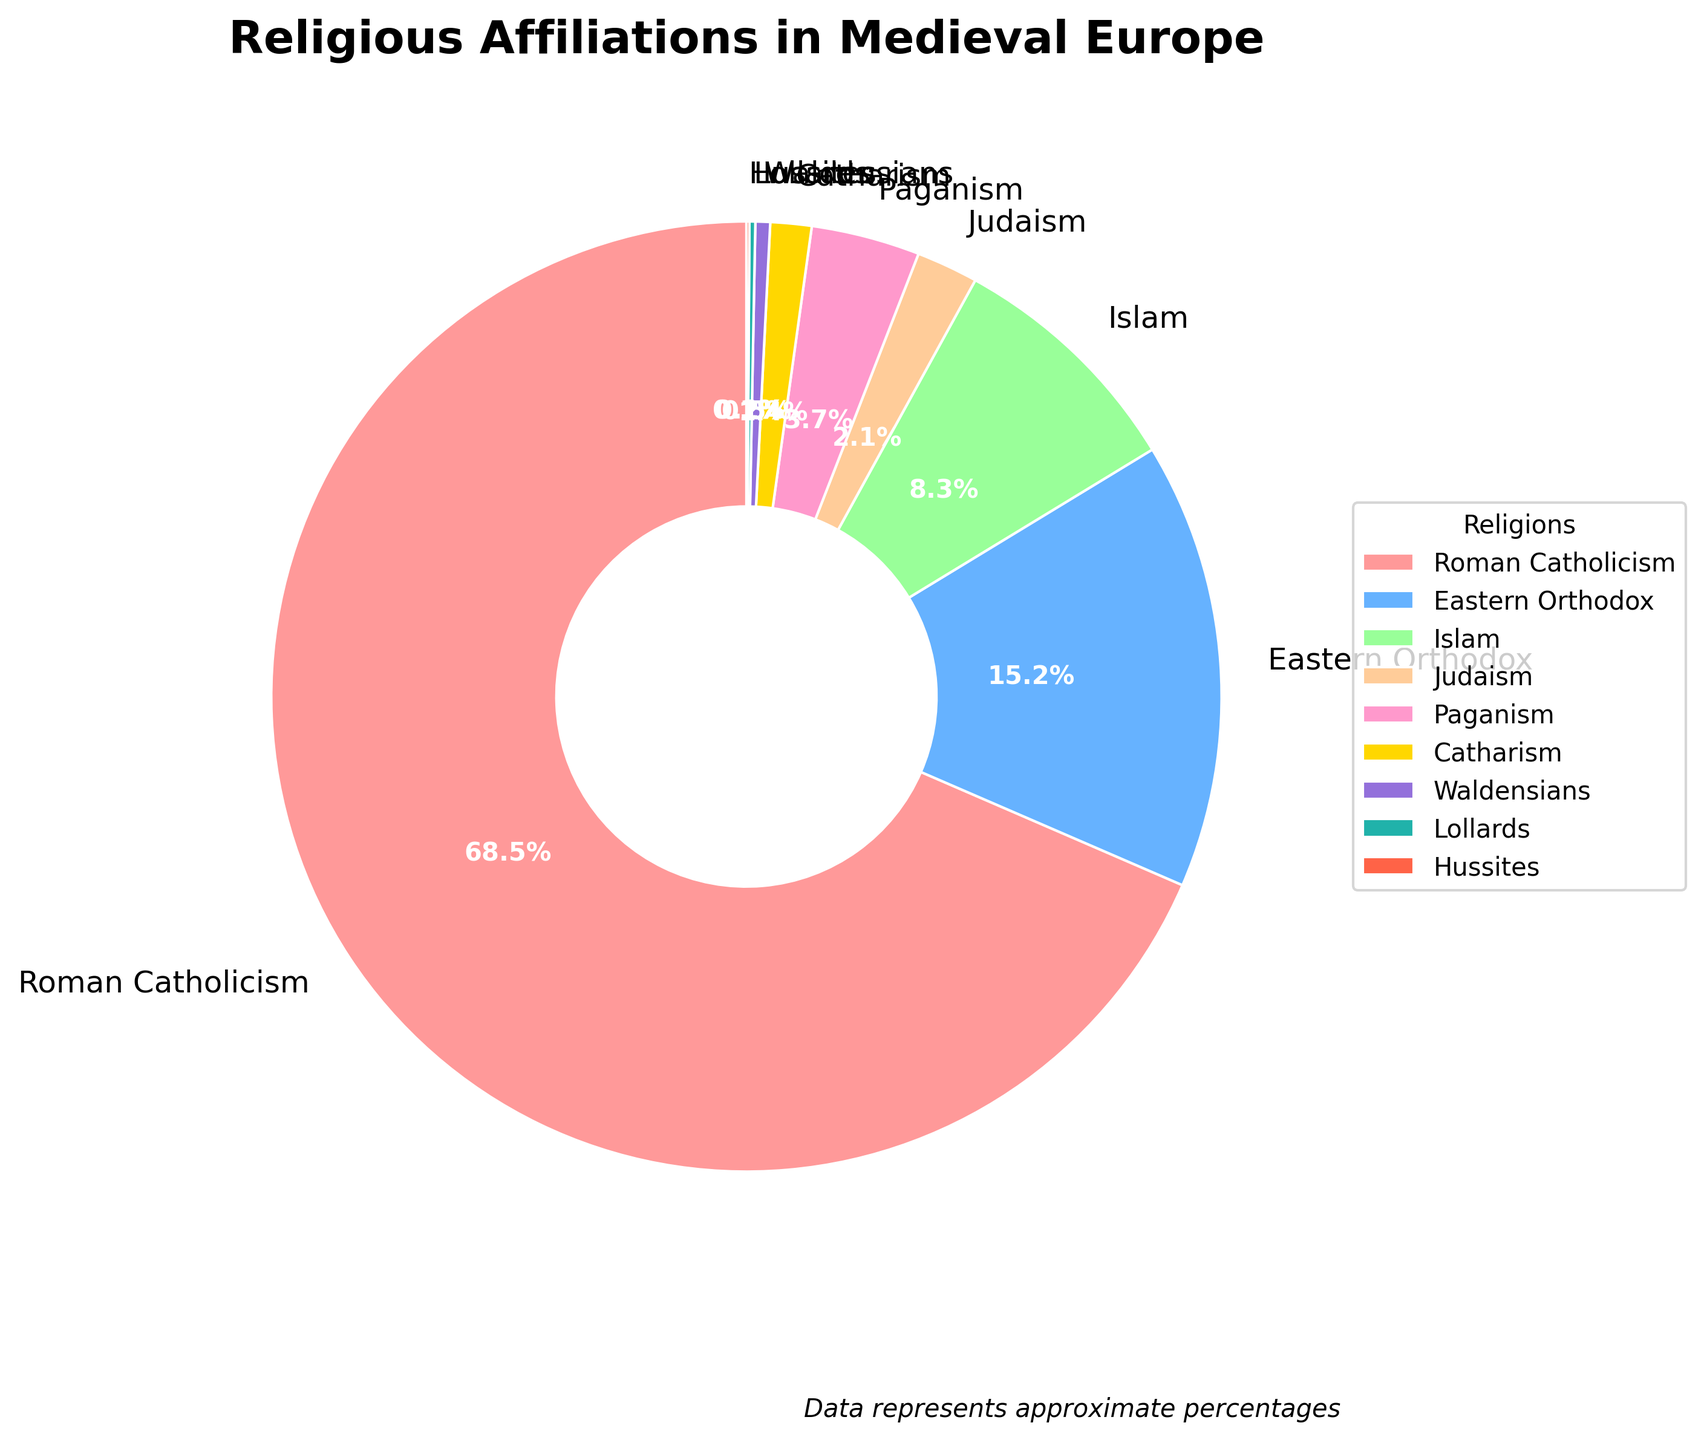What percentage of people followed monotheistic religions? Monotheistic religions in the chart include Roman Catholicism (68.5%), Eastern Orthodox (15.2%), Islam (8.3%), Judaism (2.1%), Catharism (1.4%), Waldensians (0.5%), Lollards (0.2%), and Hussites (0.1%). Adding these percentages, we get 68.5 + 15.2 + 8.3 + 2.1 + 1.4 + 0.5 + 0.2 + 0.1 = 96.3%.
Answer: 96.3% What is the difference in percentage between Roman Catholicism and Eastern Orthodox? The percentage for Roman Catholicism is 68.5%, and for Eastern Orthodox is 15.2%. Subtract 15.2% from 68.5%, giving us 68.5 - 15.2 = 53.3%.
Answer: 53.3% What is the total percentage of people following the smallest three religions shown in the chart? The smallest three religions by percentage are Hussites (0.1%), Lollards (0.2%), and Waldensians (0.5%). Adding these percentages gives 0.1 + 0.2 + 0.5 = 0.8%.
Answer: 0.8% Which is more prevalent: Judaism or Paganism, and by how much? Judaism has 2.1%, and Paganism has 3.7%. Paganism is more prevalent. The difference is 3.7 - 2.1 = 1.6%.
Answer: Paganism by 1.6% What is the combined percentage of Roman Catholicism and Islam? Roman Catholicism has 68.5%, and Islam has 8.3%. Adding these together, we get 68.5 + 8.3 = 76.8%.
Answer: 76.8% Which religion is represented by the yellow color in the chart? Upon inspection of the chart, the yellow color represents Catholicism.
Answer: Catholicism Among the given religions, which one has the closest percentage to 5% and what is its name? Paganism, with 3.7%, is the closest percentage to 5% among the given religions.
Answer: Paganism Is the percentage of followers of Eastern Orthodox greater than the total percentage of those following Judaism, Paganism, and Catharism combined? Judaism has 2.1%, Paganism has 3.7%, and Catharism has 1.4%. The sum is 2.1 + 3.7 + 1.4 = 7.2%. Since 15.2% (Eastern Orthodox) is greater than 7.2%, the statement is true.
Answer: Yes What's the predominant religion displayed in the chart, and what is its percentage? The chart shows that Roman Catholicism is the predominant religion with 68.5%.
Answer: Roman Catholicism, 68.5% 